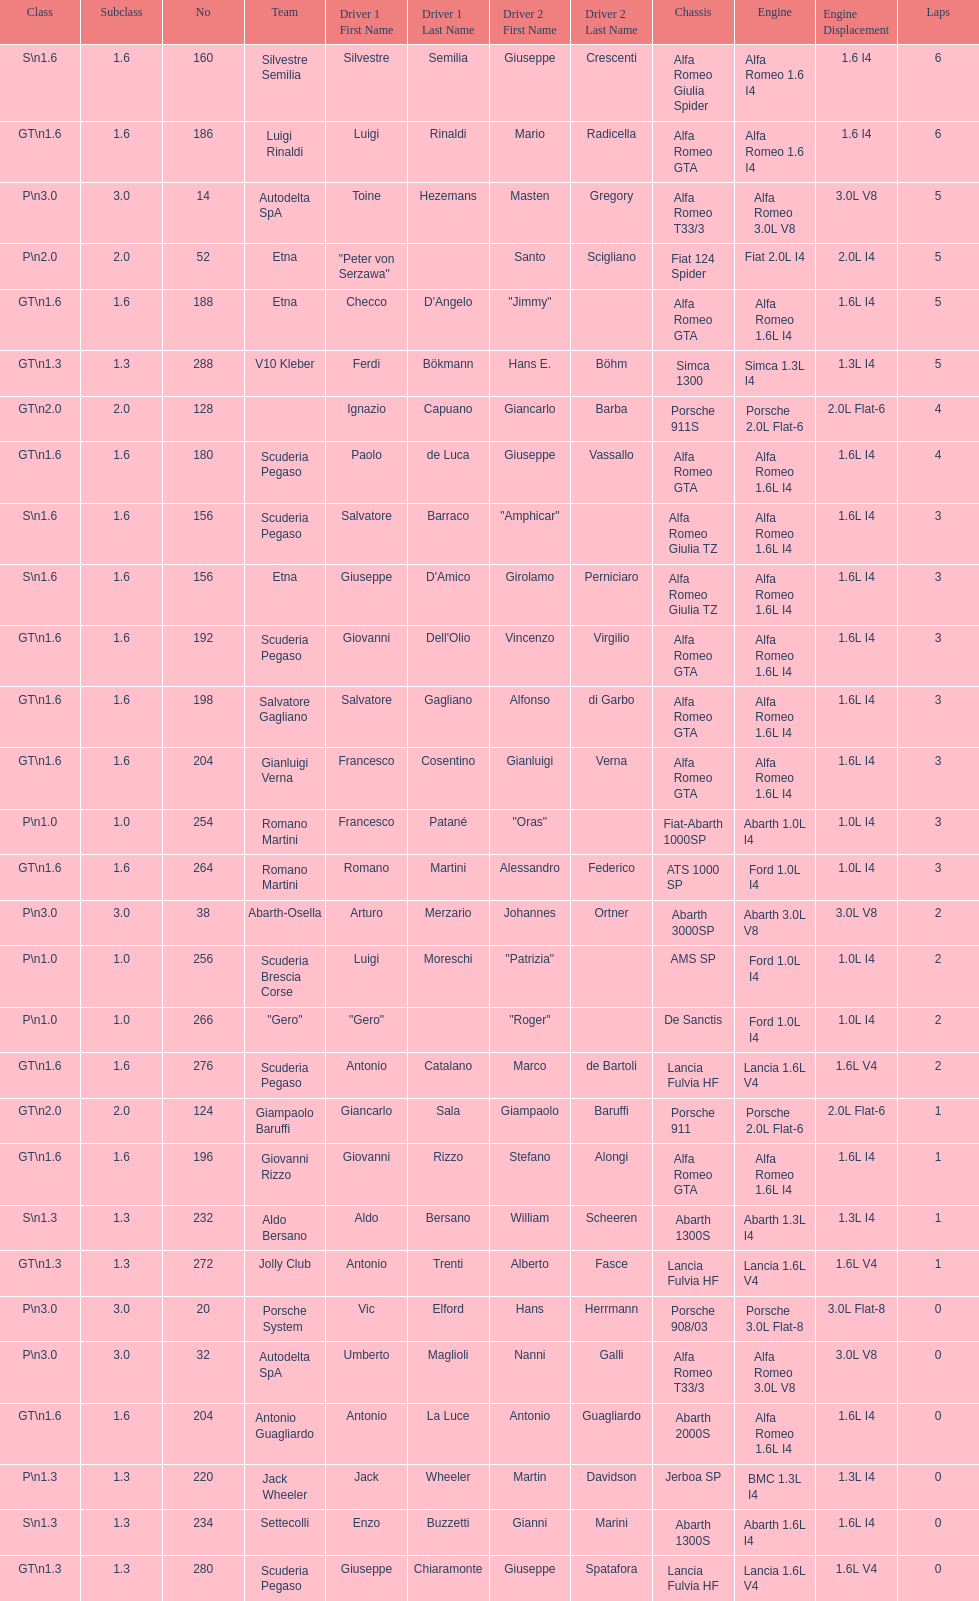How many teams failed to finish the race after 2 laps? 4. 